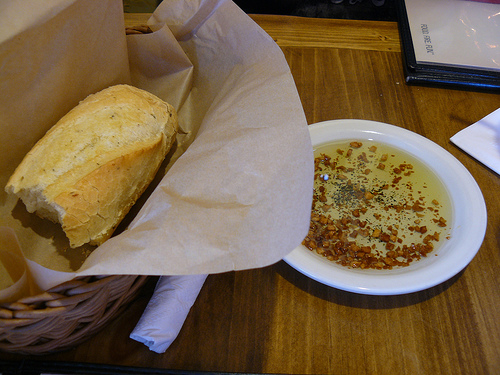<image>
Can you confirm if the bread is on the oil? No. The bread is not positioned on the oil. They may be near each other, but the bread is not supported by or resting on top of the oil. 